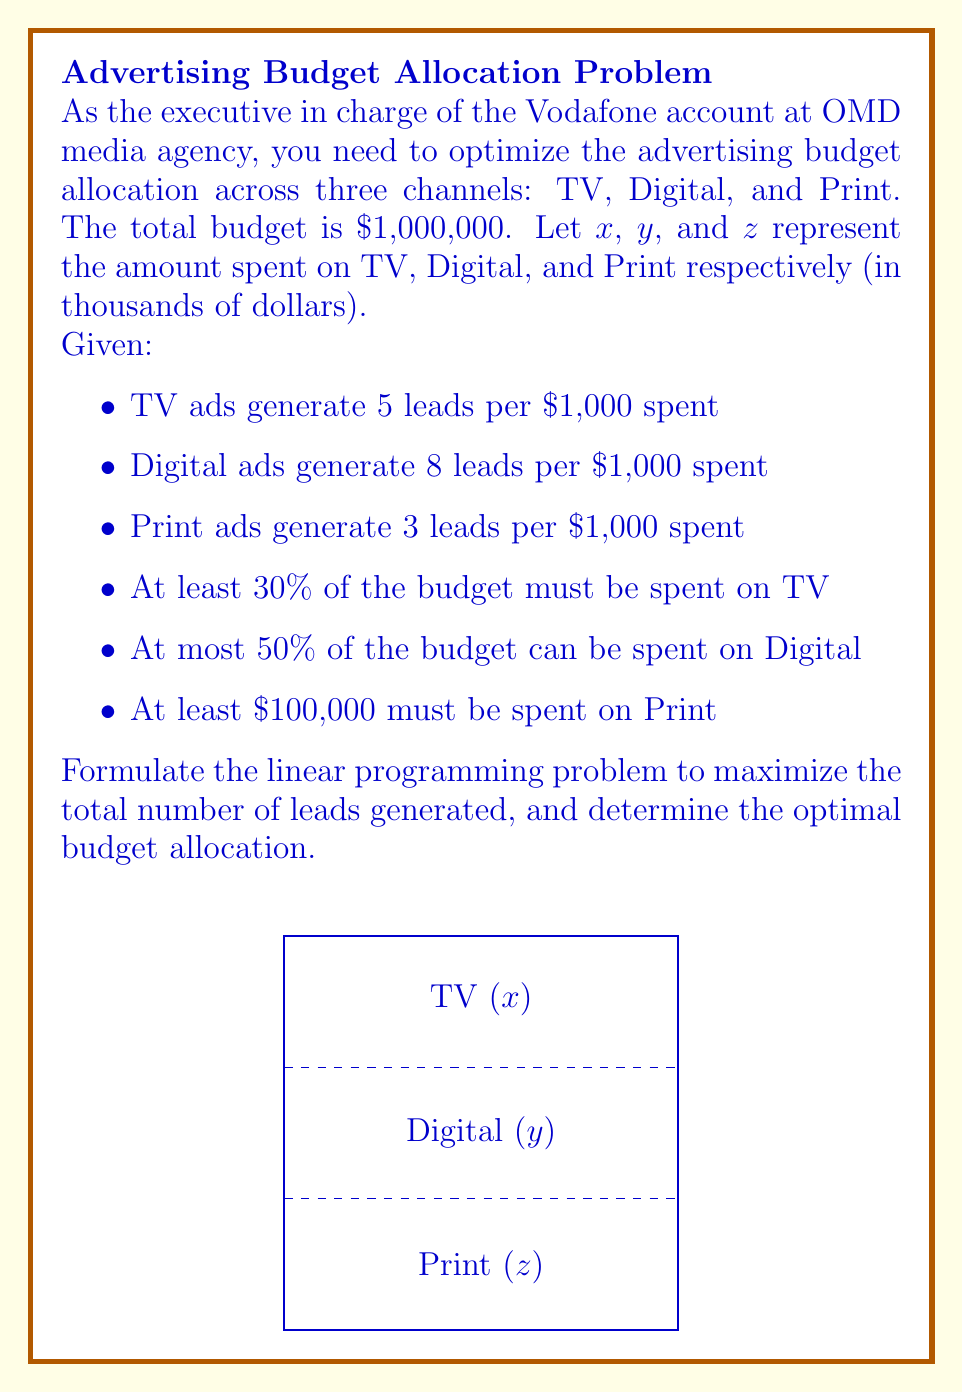Help me with this question. Let's formulate the linear programming problem step by step:

1) Objective function:
   Maximize total leads: $$ 5x + 8y + 3z $$

2) Constraints:
   a) Total budget: $x + y + z = 1000$
   b) TV at least 30%: $x \geq 300$
   c) Digital at most 50%: $y \leq 500$
   d) Print at least $100,000: $z \geq 100$
   e) Non-negativity: $x, y, z \geq 0$

3) To solve this, we can use the simplex method or linear programming software. However, we can also reason through it:

   - Digital ads generate the most leads per dollar, so we should maximize this within the constraint.
   - After Digital, TV is next most effective, so we should allocate the minimum required to TV.
   - The remaining budget goes to Print, which satisfies its minimum requirement.

4) Optimal allocation:
   Digital (y): 500 (maximum allowed)
   TV (x): 300 (minimum required)
   Print (z): 200 (remainder of budget)

5) Verify constraints:
   500 + 300 + 200 = 1000 (total budget)
   300 ≥ 300 (TV minimum)
   500 ≤ 500 (Digital maximum)
   200 ≥ 100 (Print minimum)

6) Calculate total leads:
   $5(300) + 8(500) + 3(200) = 1500 + 4000 + 600 = 6100$ leads
Answer: Optimal allocation: $300,000 on TV, $500,000 on Digital, $200,000 on Print; generating 6,100 leads. 